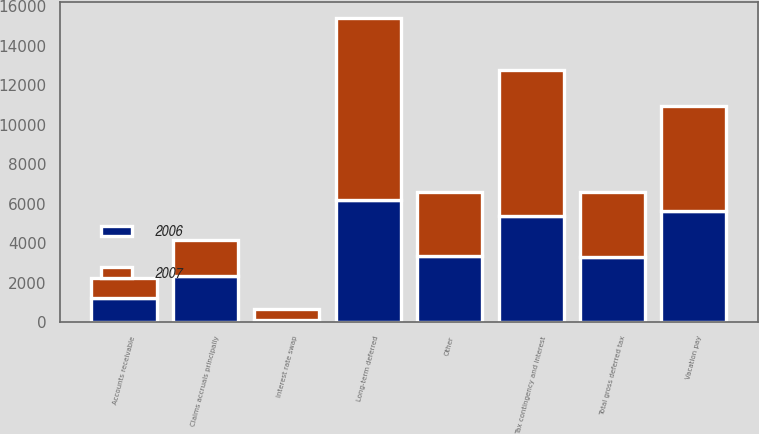<chart> <loc_0><loc_0><loc_500><loc_500><stacked_bar_chart><ecel><fcel>Claims accruals principally<fcel>Accounts receivable<fcel>Vacation pay<fcel>Long-term deferred<fcel>Tax contingency and interest<fcel>Interest rate swap<fcel>Other<fcel>Total gross deferred tax<nl><fcel>2007<fcel>1865<fcel>1037<fcel>5308<fcel>9227<fcel>7422<fcel>554<fcel>3222<fcel>3288<nl><fcel>2006<fcel>2311<fcel>1221<fcel>5614<fcel>6190<fcel>5353<fcel>95<fcel>3354<fcel>3288<nl></chart> 